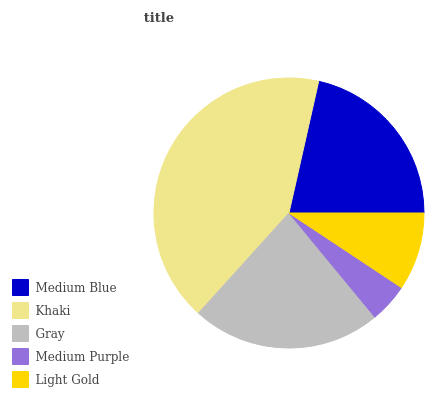Is Medium Purple the minimum?
Answer yes or no. Yes. Is Khaki the maximum?
Answer yes or no. Yes. Is Gray the minimum?
Answer yes or no. No. Is Gray the maximum?
Answer yes or no. No. Is Khaki greater than Gray?
Answer yes or no. Yes. Is Gray less than Khaki?
Answer yes or no. Yes. Is Gray greater than Khaki?
Answer yes or no. No. Is Khaki less than Gray?
Answer yes or no. No. Is Medium Blue the high median?
Answer yes or no. Yes. Is Medium Blue the low median?
Answer yes or no. Yes. Is Khaki the high median?
Answer yes or no. No. Is Light Gold the low median?
Answer yes or no. No. 